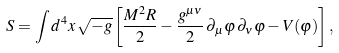<formula> <loc_0><loc_0><loc_500><loc_500>S = \int d ^ { 4 } x \, \sqrt { - g } \left [ \frac { M ^ { 2 } R } { 2 } - \frac { g ^ { \mu \nu } } { 2 } \, \partial _ { \mu } \varphi \, \partial _ { \nu } \varphi - V ( \varphi ) \right ] ,</formula> 